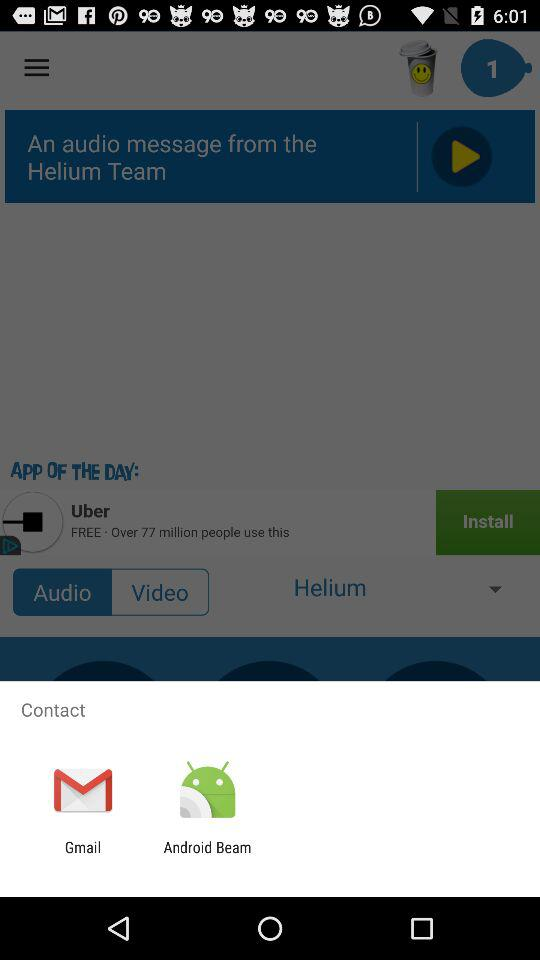From where is the message received? The message is received from "Helium Team". 